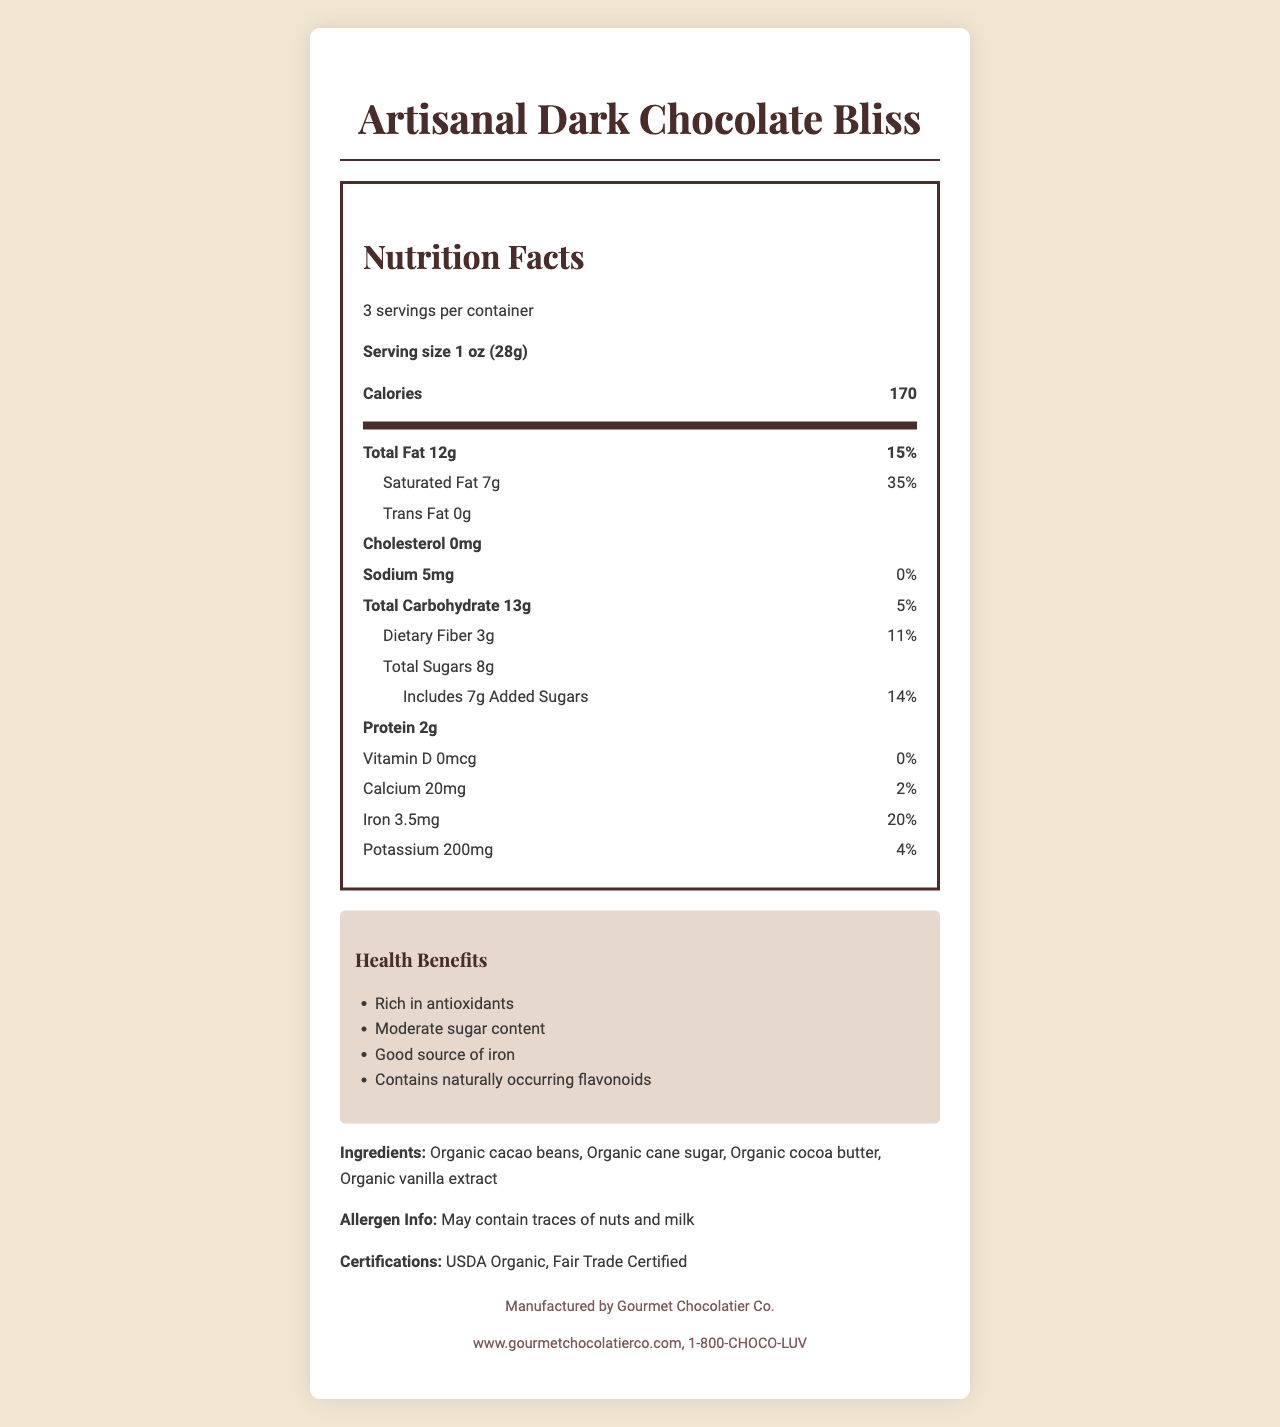what is the serving size of the product? The serving size is clearly stated in the "Nutrition Facts" section.
Answer: 1 oz (28g) how many servings are in the container? The document mentions the number of servings per container in the "Nutrition Facts" section.
Answer: 3 servings per container how many calories are in one serving? The document lists the amount of calories per serving in the "Nutrition Facts" section.
Answer: 170 calories what is the total fat content per serving? The total fat content per serving is specified in the "Nutrition Facts" section.
Answer: 12g is there any trans fat in the chocolate bar? The "Nutrition Facts" section states that the trans fat amount is 0g.
Answer: No what is the percentage of daily value for saturated fat? The daily value percentage for saturated fat is provided in the "Nutrition Facts" section.
Answer: 35% how much iron does one serving contain? The document lists the amount of iron in the "Nutrition Facts" section.
Answer: 3.5mg what is the amount of added sugars in one serving? A. 6g B. 7g C. 8g D. 9g The "Nutrition Facts" section states that the amount of added sugars is 7g.
Answer: B. 7g which nutrients are highlighted for their antioxidant properties? A. Vitamin C and Zinc B. Flavonoids and Polyphenols C. Fiber and Protein D. Calcium and Vitamin D The document mentions flavonoids and polyphenols as nutrients with antioxidant properties.
Answer: B. Flavonoids and Polyphenols does the chocolate bar contain any cholesterol? The "Nutrition Facts" section lists 0mg for cholesterol.
Answer: No describe the main idea of the document. This detailed explanation covers the main aspects presented in the document, including nutritional values, ingredients, health claims, and additional information about the product.
Answer: The document provides the nutrition facts for "Artisanal Dark Chocolate Bliss," highlights its antioxidant properties, moderate sugar content, and health benefits, and includes information about ingredients, allergen info, certifications, and manufacturer details. who is the manufacturer of the chocolate bar? The footer section of the document names "Gourmet Chocolatier Co." as the manufacturer.
Answer: Gourmet Chocolatier Co. how can customers contact the manufacturer? The document provides contact information in the footer section.
Answer: www.gourmetchocolatierco.com, 1-800-CHOCO-LUV is this chocolate bar a good source of vitamin D? The "Nutrition Facts" section shows that the vitamin D content is 0mcg and 0% daily value.
Answer: No what percent of daily value of sodium does one serving contain? The document states the daily value percentage for sodium as 0% in the "Nutrition Facts" section.
Answer: 0% can you determine the exact flavor profile of the chocolate from this document? The document does not provide specific details about the flavor profile of the chocolate.
Answer: Cannot be determined what organization certified the chocolate as organic? The document lists "USDA Organic" under the certifications section.
Answer: USDA Organic 